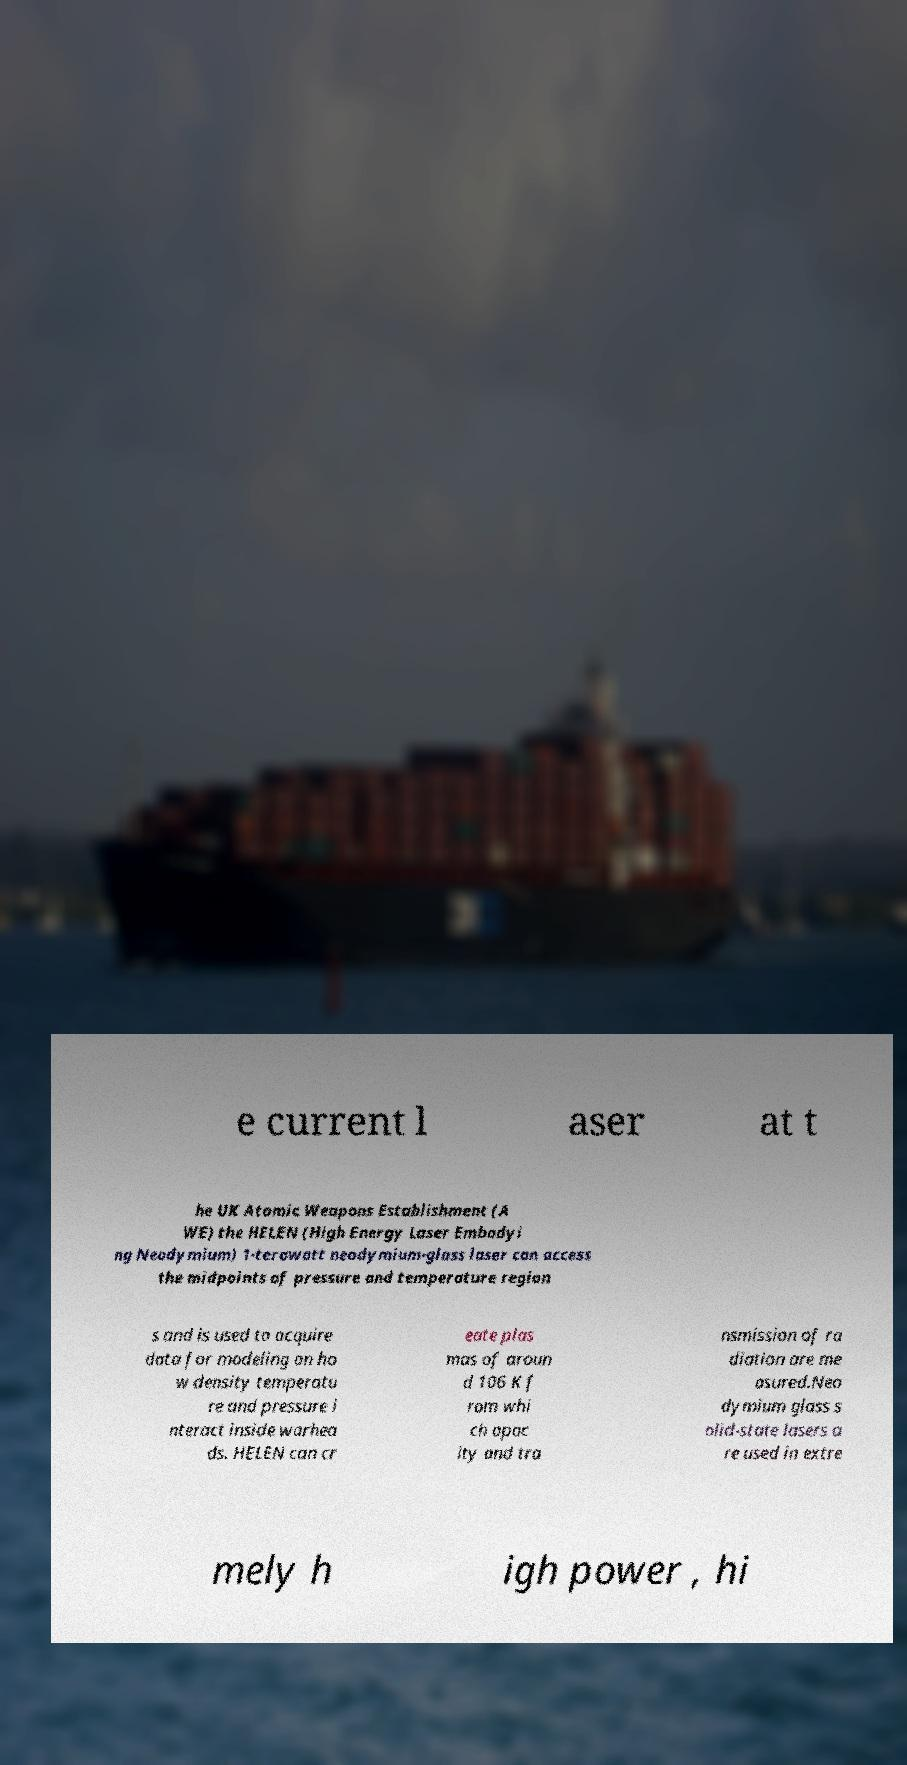Could you extract and type out the text from this image? e current l aser at t he UK Atomic Weapons Establishment (A WE) the HELEN (High Energy Laser Embodyi ng Neodymium) 1-terawatt neodymium-glass laser can access the midpoints of pressure and temperature region s and is used to acquire data for modeling on ho w density temperatu re and pressure i nteract inside warhea ds. HELEN can cr eate plas mas of aroun d 106 K f rom whi ch opac ity and tra nsmission of ra diation are me asured.Neo dymium glass s olid-state lasers a re used in extre mely h igh power , hi 